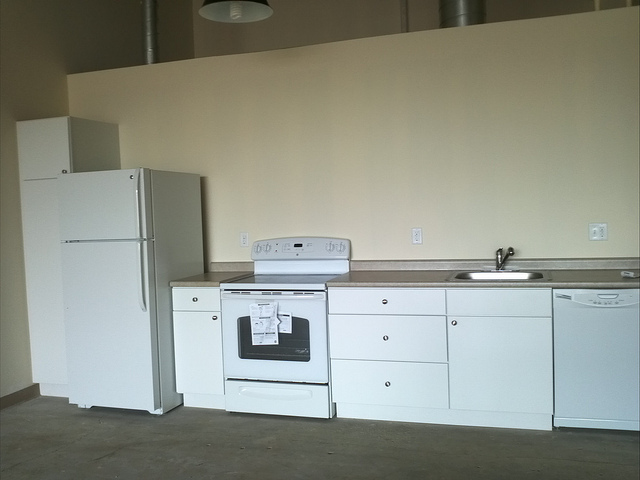<image>Which drawer is open? There is no open drawer in the image. Which drawer is open? There is no open drawer in the image. 